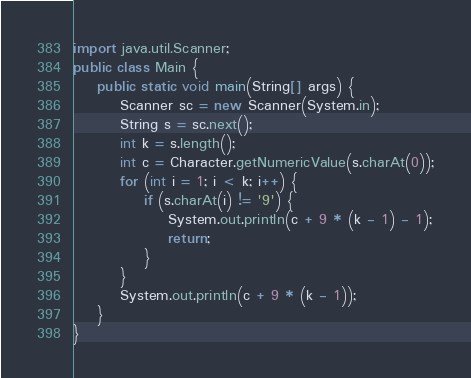Convert code to text. <code><loc_0><loc_0><loc_500><loc_500><_Java_>import java.util.Scanner;
public class Main {
    public static void main(String[] args) {
        Scanner sc = new Scanner(System.in);
        String s = sc.next();
        int k = s.length();
        int c = Character.getNumericValue(s.charAt(0));
        for (int i = 1; i < k; i++) {
            if (s.charAt(i) != '9') {
                System.out.println(c + 9 * (k - 1) - 1);
                return;
            }
        }
        System.out.println(c + 9 * (k - 1));
    }
}
</code> 